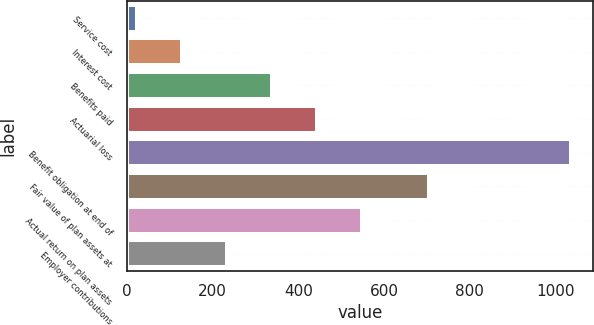Convert chart. <chart><loc_0><loc_0><loc_500><loc_500><bar_chart><fcel>Service cost<fcel>Interest cost<fcel>Benefits paid<fcel>Actuarial loss<fcel>Benefit obligation at end of<fcel>Fair value of plan assets at<fcel>Actual return on plan assets<fcel>Employer contributions<nl><fcel>23<fcel>128.1<fcel>338.3<fcel>443.4<fcel>1035<fcel>705<fcel>548.5<fcel>233.2<nl></chart> 